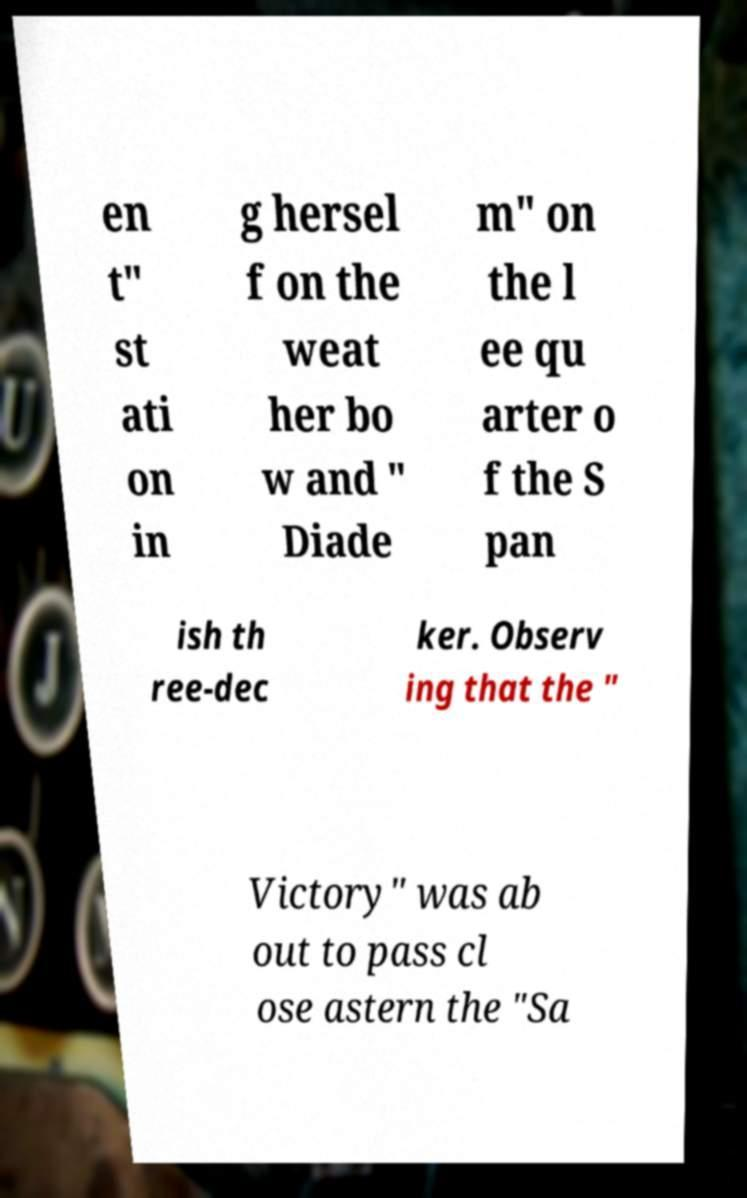I need the written content from this picture converted into text. Can you do that? en t" st ati on in g hersel f on the weat her bo w and " Diade m" on the l ee qu arter o f the S pan ish th ree-dec ker. Observ ing that the " Victory" was ab out to pass cl ose astern the "Sa 